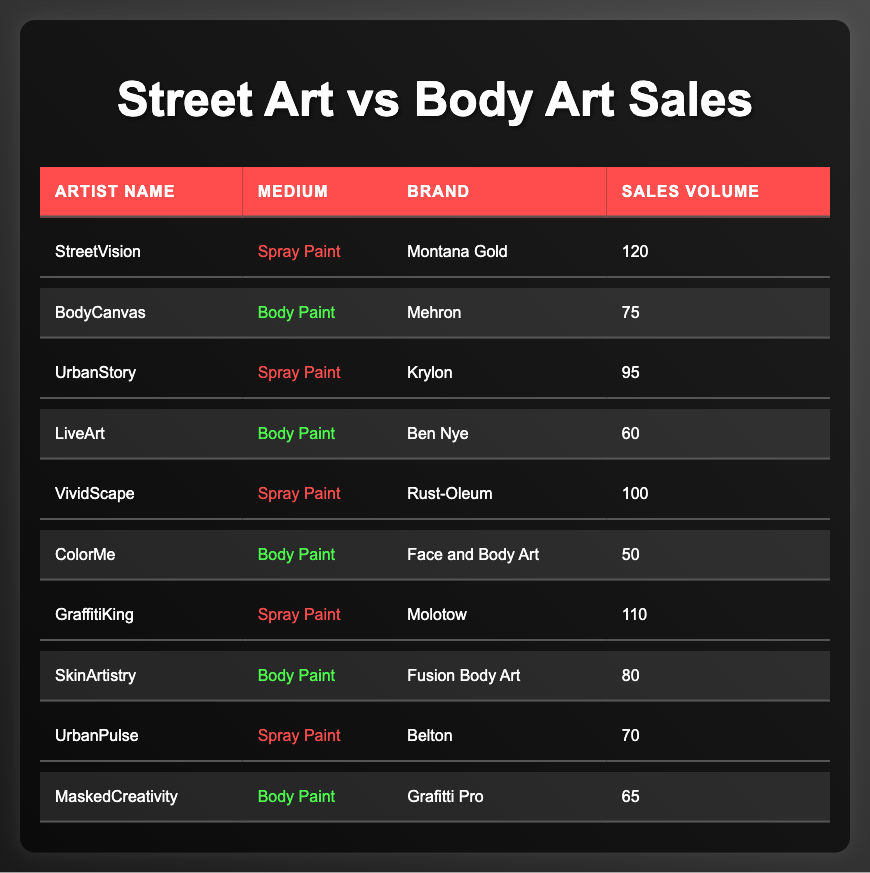What is the total sales volume for Spray Paint? To find the total sales volume for Spray Paint, I will add the sales volumes of all the artists who used this medium: 120 (Montana Gold) + 95 (Krylon) + 100 (Rust-Oleum) + 110 (Molotow) + 70 (Belton) = 595.
Answer: 595 What is the brand with the highest sales volume among Body Paint? By examining the sales volumes of the Body Paint artists, I see that Mehron has 75, Ben Nye has 60, Face and Body Art has 50, Fusion Body Art has 80, and Grafitti Pro has 65. The highest sales volume is 80 for Fusion Body Art.
Answer: Fusion Body Art What is the average sales volume for all artists using Spray Paint? There are 5 artists using Spray Paint with sales volumes of 120, 95, 100, 110, and 70. The sum is 120 + 95 + 100 + 110 + 70 = 595. To find the average, I divide this by 5 (595/5 = 119).
Answer: 119 Did more artists sell Body Paint than Spray Paint? There are 5 artists selling Body Paint (BodyCanvas, LiveArt, ColorMe, SkinArtistry, MaskedCreativity) and 5 artists selling Spray Paint (StreetVision, UrbanStory, VividScape, GraffitiKing, UrbanPulse). Since the numbers are equal, the answer is no.
Answer: No What is the total sales volume for Body Paint? To find the total sales volume for Body Paint, I will add the sales volumes of the Body Paint artists: 75 (Mehron) + 60 (Ben Nye) + 50 (Face and Body Art) + 80 (Fusion Body Art) + 65 (Grafitti Pro) = 330.
Answer: 330 Which Spray Paint brand sold the least? The Spray Paint brands and their sales volumes are Montana Gold (120), Krylon (95), Rust-Oleum (100), Molotow (110), and Belton (70). The least sales volume is 70 from the brand Belton.
Answer: Belton What is the difference in sales volume between the top-selling Spray Paint brand and the top-selling Body Paint brand? The top-selling Spray Paint brand is Montana Gold with 120 sales, while the top-selling Body Paint brand is Fusion Body Art with 80 sales. The difference is calculated as 120 - 80 = 40.
Answer: 40 How many artists have sales volumes over 80 for Body Paint? The Body Paint artists and their sales volumes are: 75 (Mehron), 60 (Ben Nye), 50 (Face and Body Art), 80 (Fusion Body Art), and 65 (Grafitti Pro). Only 1 artist (Fusion Body Art) has a sales volume of over 80.
Answer: 1 What is the combined sales volume of Krylon and Rust-Oleum? The sales volumes for Krylon and Rust-Oleum are 95 and 100, respectively. I will combine them by adding the two values: 95 + 100 = 195.
Answer: 195 